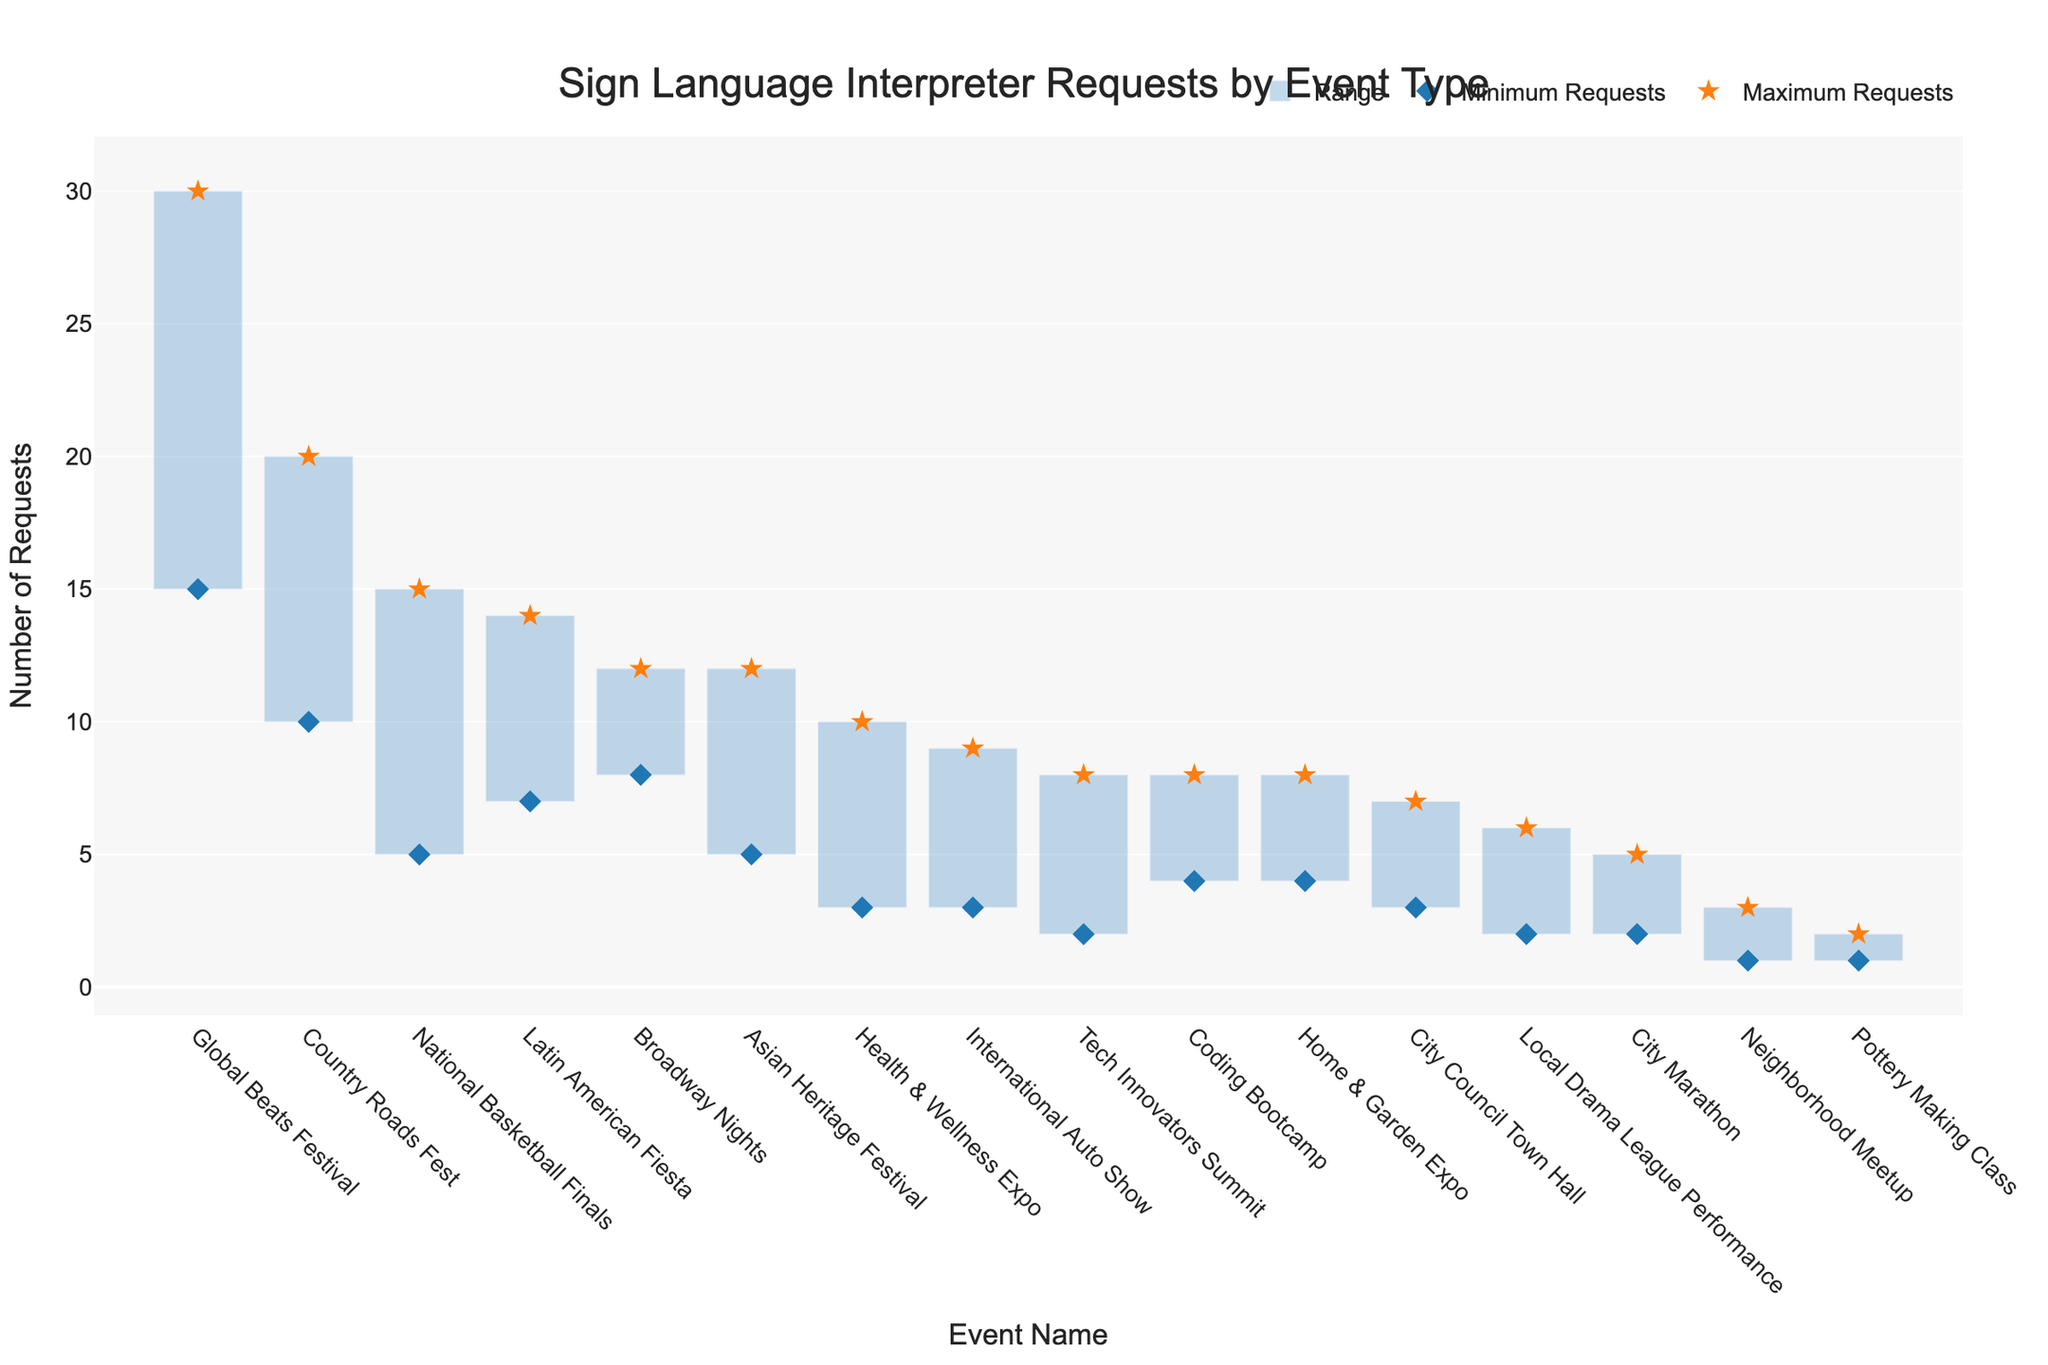What's the title of the plot? The title is usually found at the top of the plot. It often summarizes the main focus or data being presented in the visual. Here, the title reads "Sign Language Interpreter Requests by Event Type".
Answer: Sign Language Interpreter Requests by Event Type What's the range of interpreter requests for the Music Festival "Global Beats Festival"? The minimum and maximum points for each event show the range. For the "Global Beats Festival", the minimum requests are 15 and the maximum requests are 30. The range is calculated by subtracting the minimum from the maximum.
Answer: 15 Which event type has the highest maximum number of sign language interpreter requests? By examining the figure, we identify the event with the highest peak. The "Global Beats Festival" under Music Festivals has a maximum of 30 requests, the highest among all events.
Answer: Music Festival - Global Beats Festival What is the difference in interpreter requests between "Health & Wellness Expo" and "Pottery Making Class"? For each event, we subtract the minimum from the maximum number of requests and compute the difference between these ranges. "Health & Wellness Expo": 10 - 3 = 7; "Pottery Making Class": 2 - 1 = 1.
Answer: 6 How does the range of interpreter requests for the "Coding Bootcamp" compare to that of the "Tech Innovators Summit"? Calculate the range of both events: "Coding Bootcamp" (4-8), (8-4=4). "Tech Innovators Summit" (2-8), (8-2=6). Compare the two ranges, noting that Coding Bootcamp has a smaller range.
Answer: Coding Bootcamp has a smaller range Which event has the smallest minimum number of interpreter requests, and what is it? Identify the event with the lowest point on the figure. The "Pottery Making Class" has a minimum of 1 request, the smallest among all events.
Answer: Pottery Making Class, 1 Between "Country Roads Fest" and "City Marathon", which event generally requires more interpreters? By comparing both the minimum and maximum requests for each event, "Country Roads Fest" has ranges (10-20) and "City Marathon" has (2-5). Both minimum and maximum requests are higher for "Country Roads Fest".
Answer: Country Roads Fest What is the average number of maximum interpreter requests for all types of cultural festivals? First identify all cultural festivals and their maximum requests: "Asian Heritage Festival" (12), "Latin American Fiesta" (14). Their average is computed as (12+14)/2 = 13.
Answer: 13 What pattern do we observe regarding interpreter requests across different event types? Observing the plot, Music Festivals like "Global Beats Festival" tend to have higher requests. Community Gatherings and Workshops have lower ranges indicating fewer interpreter requests.
Answer: Music Festivals have higher requests; Community Gatherings and Workshops have lower What's the sum of maximum interpreter requests for all sports events? Identify sports events and their maximum requests: "National Basketball Finals" (15), "City Marathon" (5). Sum these values: 15 + 5 = 20.
Answer: 20 